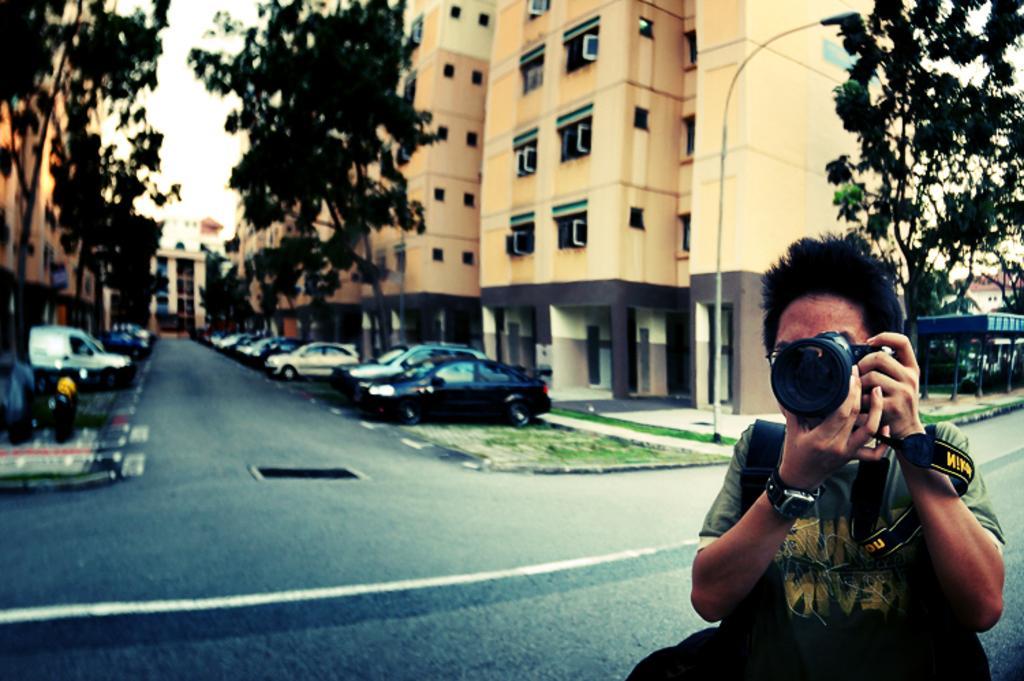Describe this image in one or two sentences. A man is capturing photographs,behind him there is a building,trees,sky and vehicles. 